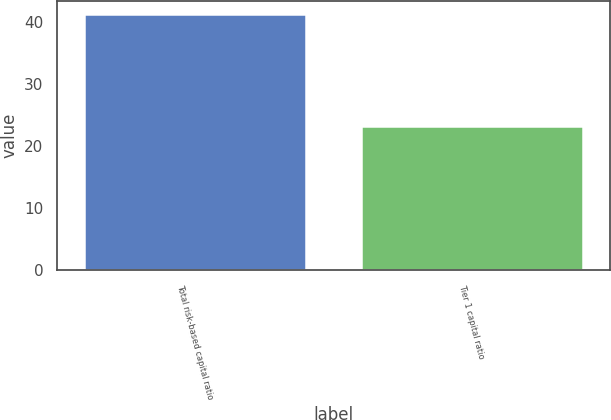<chart> <loc_0><loc_0><loc_500><loc_500><bar_chart><fcel>Total risk-based capital ratio<fcel>Tier 1 capital ratio<nl><fcel>41.3<fcel>23.2<nl></chart> 